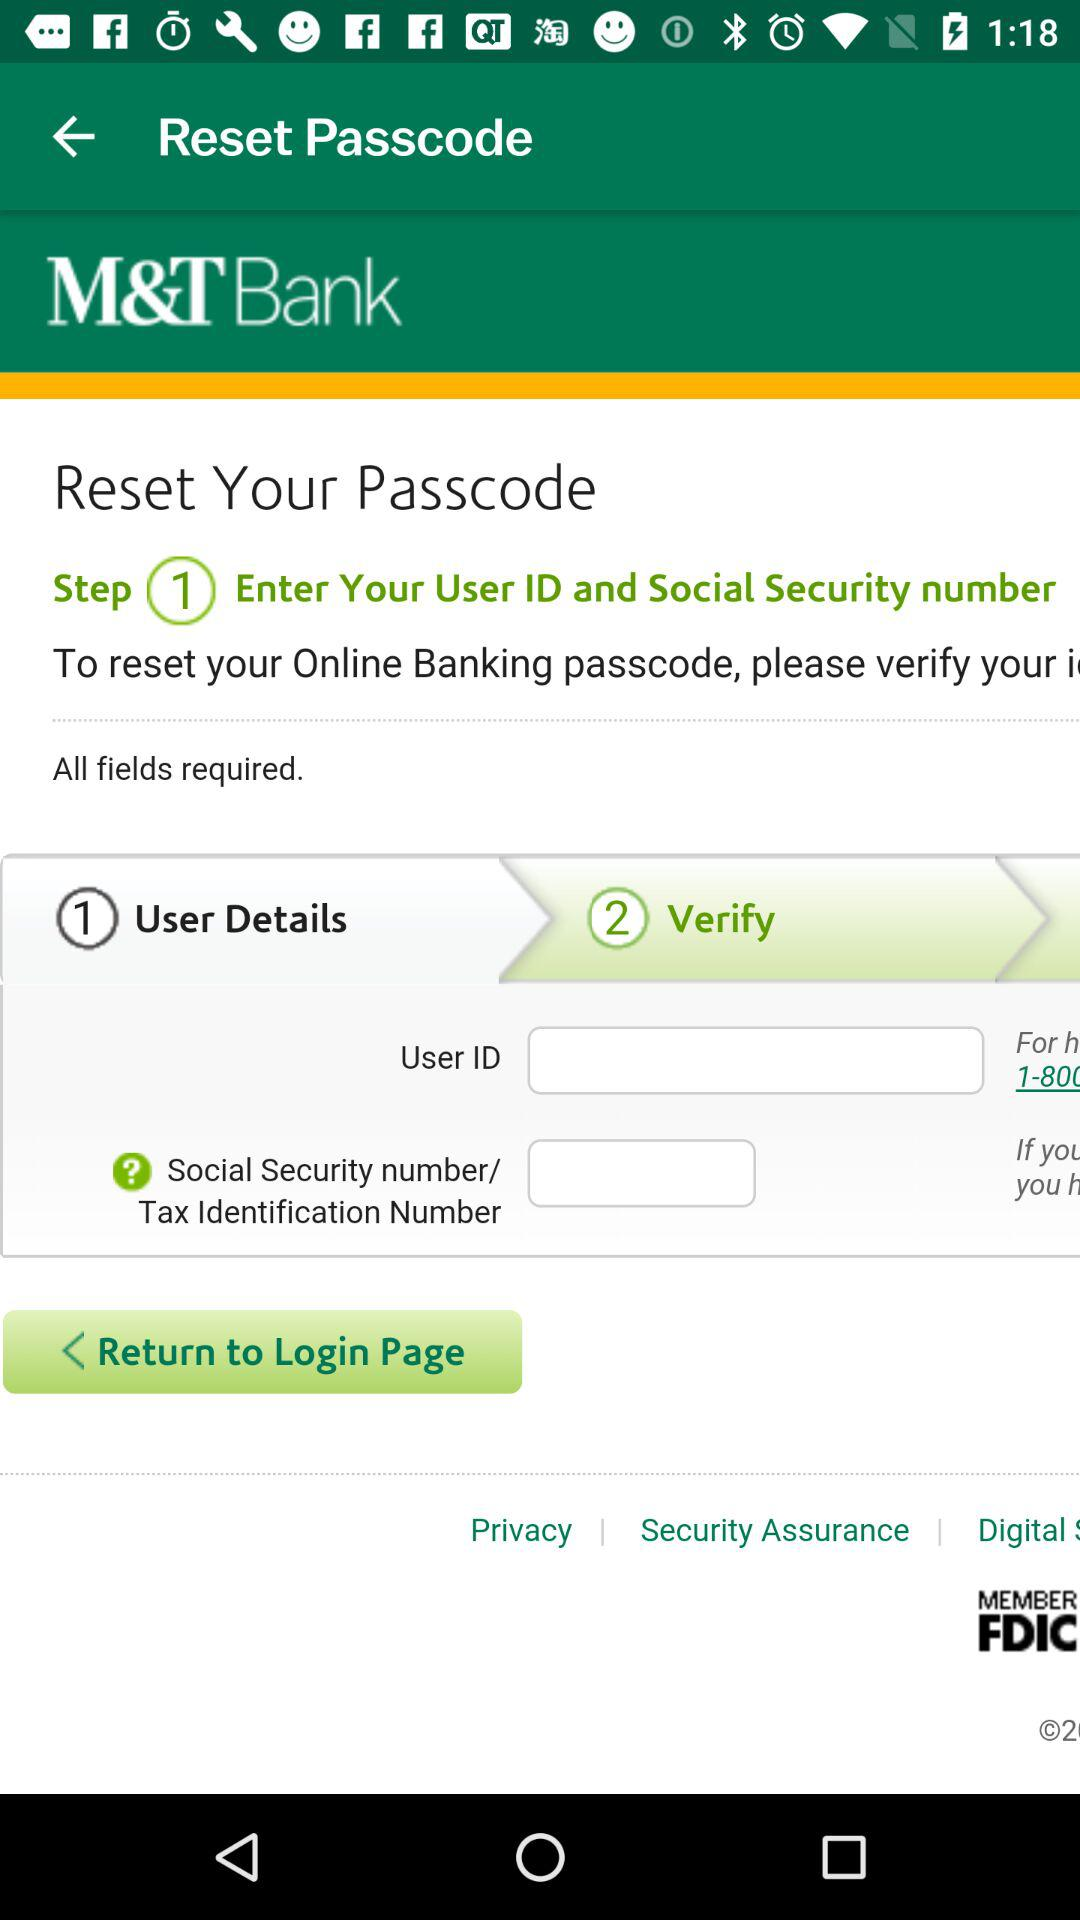How many fields are required to reset the passcode?
Answer the question using a single word or phrase. 2 